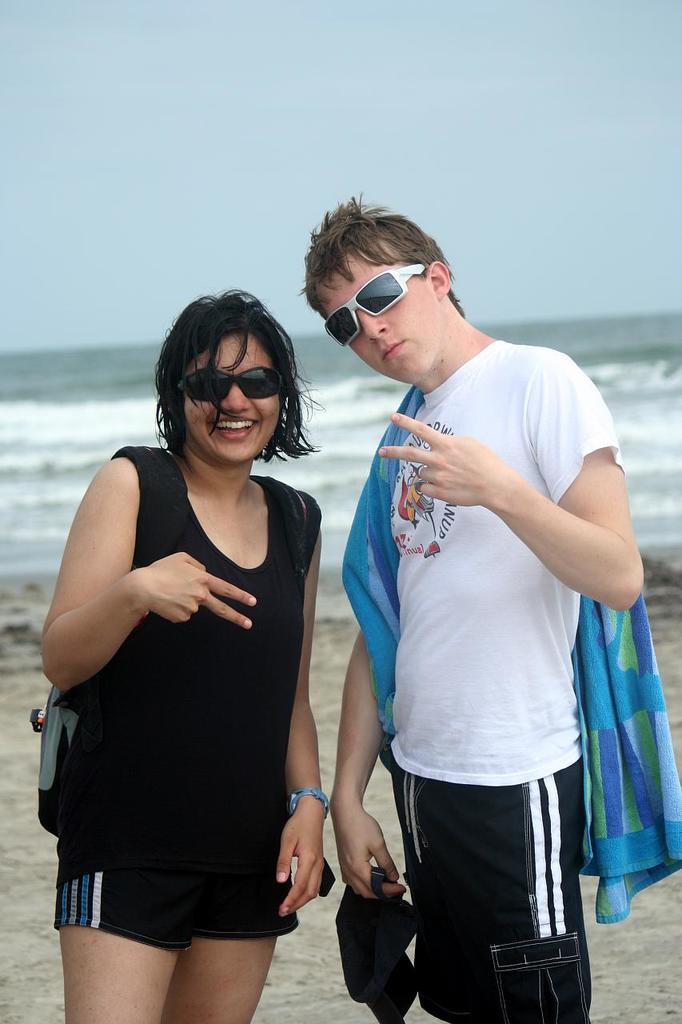How would you summarize this image in a sentence or two? In this image in the foreground there is one man and one woman standing and smiling, and they are wearing goggles. And woman is wearing bag, and holding a cap and towel and in the background there is a beach. At the bottom of the image there is sand, and at the top there is sky. 